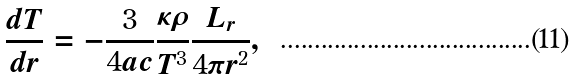Convert formula to latex. <formula><loc_0><loc_0><loc_500><loc_500>\frac { d T } { d r } = - \frac { 3 } { 4 a c } \frac { \kappa \rho } { T ^ { 3 } } \frac { L _ { r } } { 4 \pi r ^ { 2 } } ,</formula> 